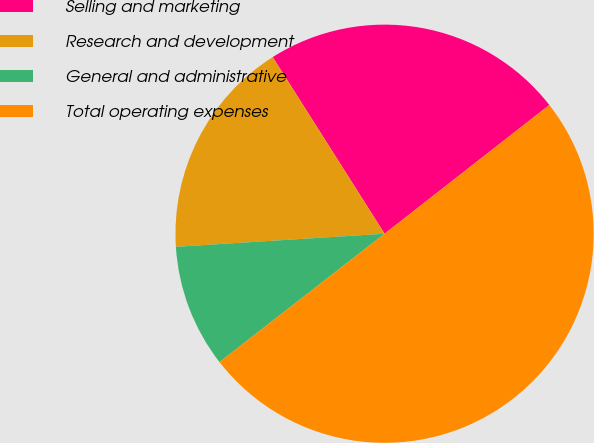Convert chart. <chart><loc_0><loc_0><loc_500><loc_500><pie_chart><fcel>Selling and marketing<fcel>Research and development<fcel>General and administrative<fcel>Total operating expenses<nl><fcel>23.43%<fcel>17.01%<fcel>9.52%<fcel>50.04%<nl></chart> 